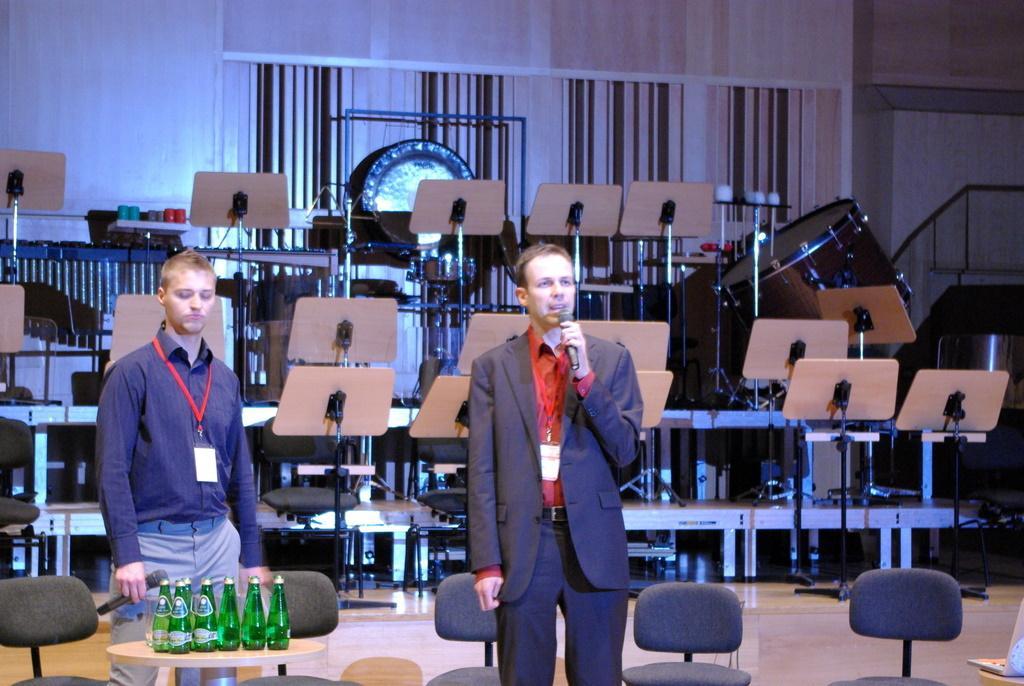How would you summarize this image in a sentence or two? In this picture we can see two men are standing and holding microphones, at the bottom there are some chairs and a table, we can see bottles on the table, in the background there are music stands, a drum and a wall. 